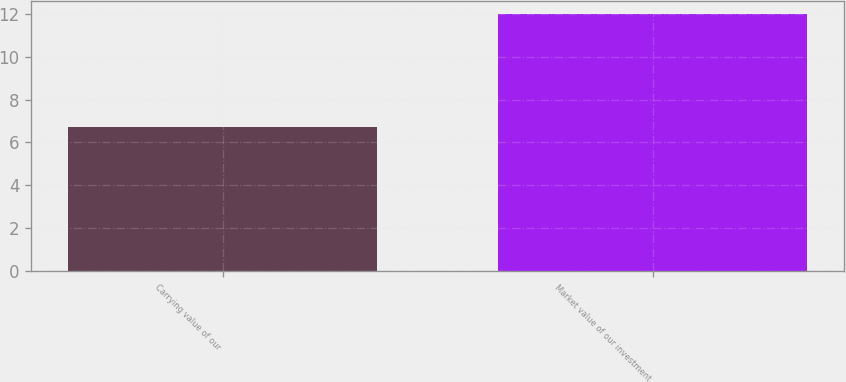Convert chart to OTSL. <chart><loc_0><loc_0><loc_500><loc_500><bar_chart><fcel>Carrying value of our<fcel>Market value of our investment<nl><fcel>6.7<fcel>12<nl></chart> 